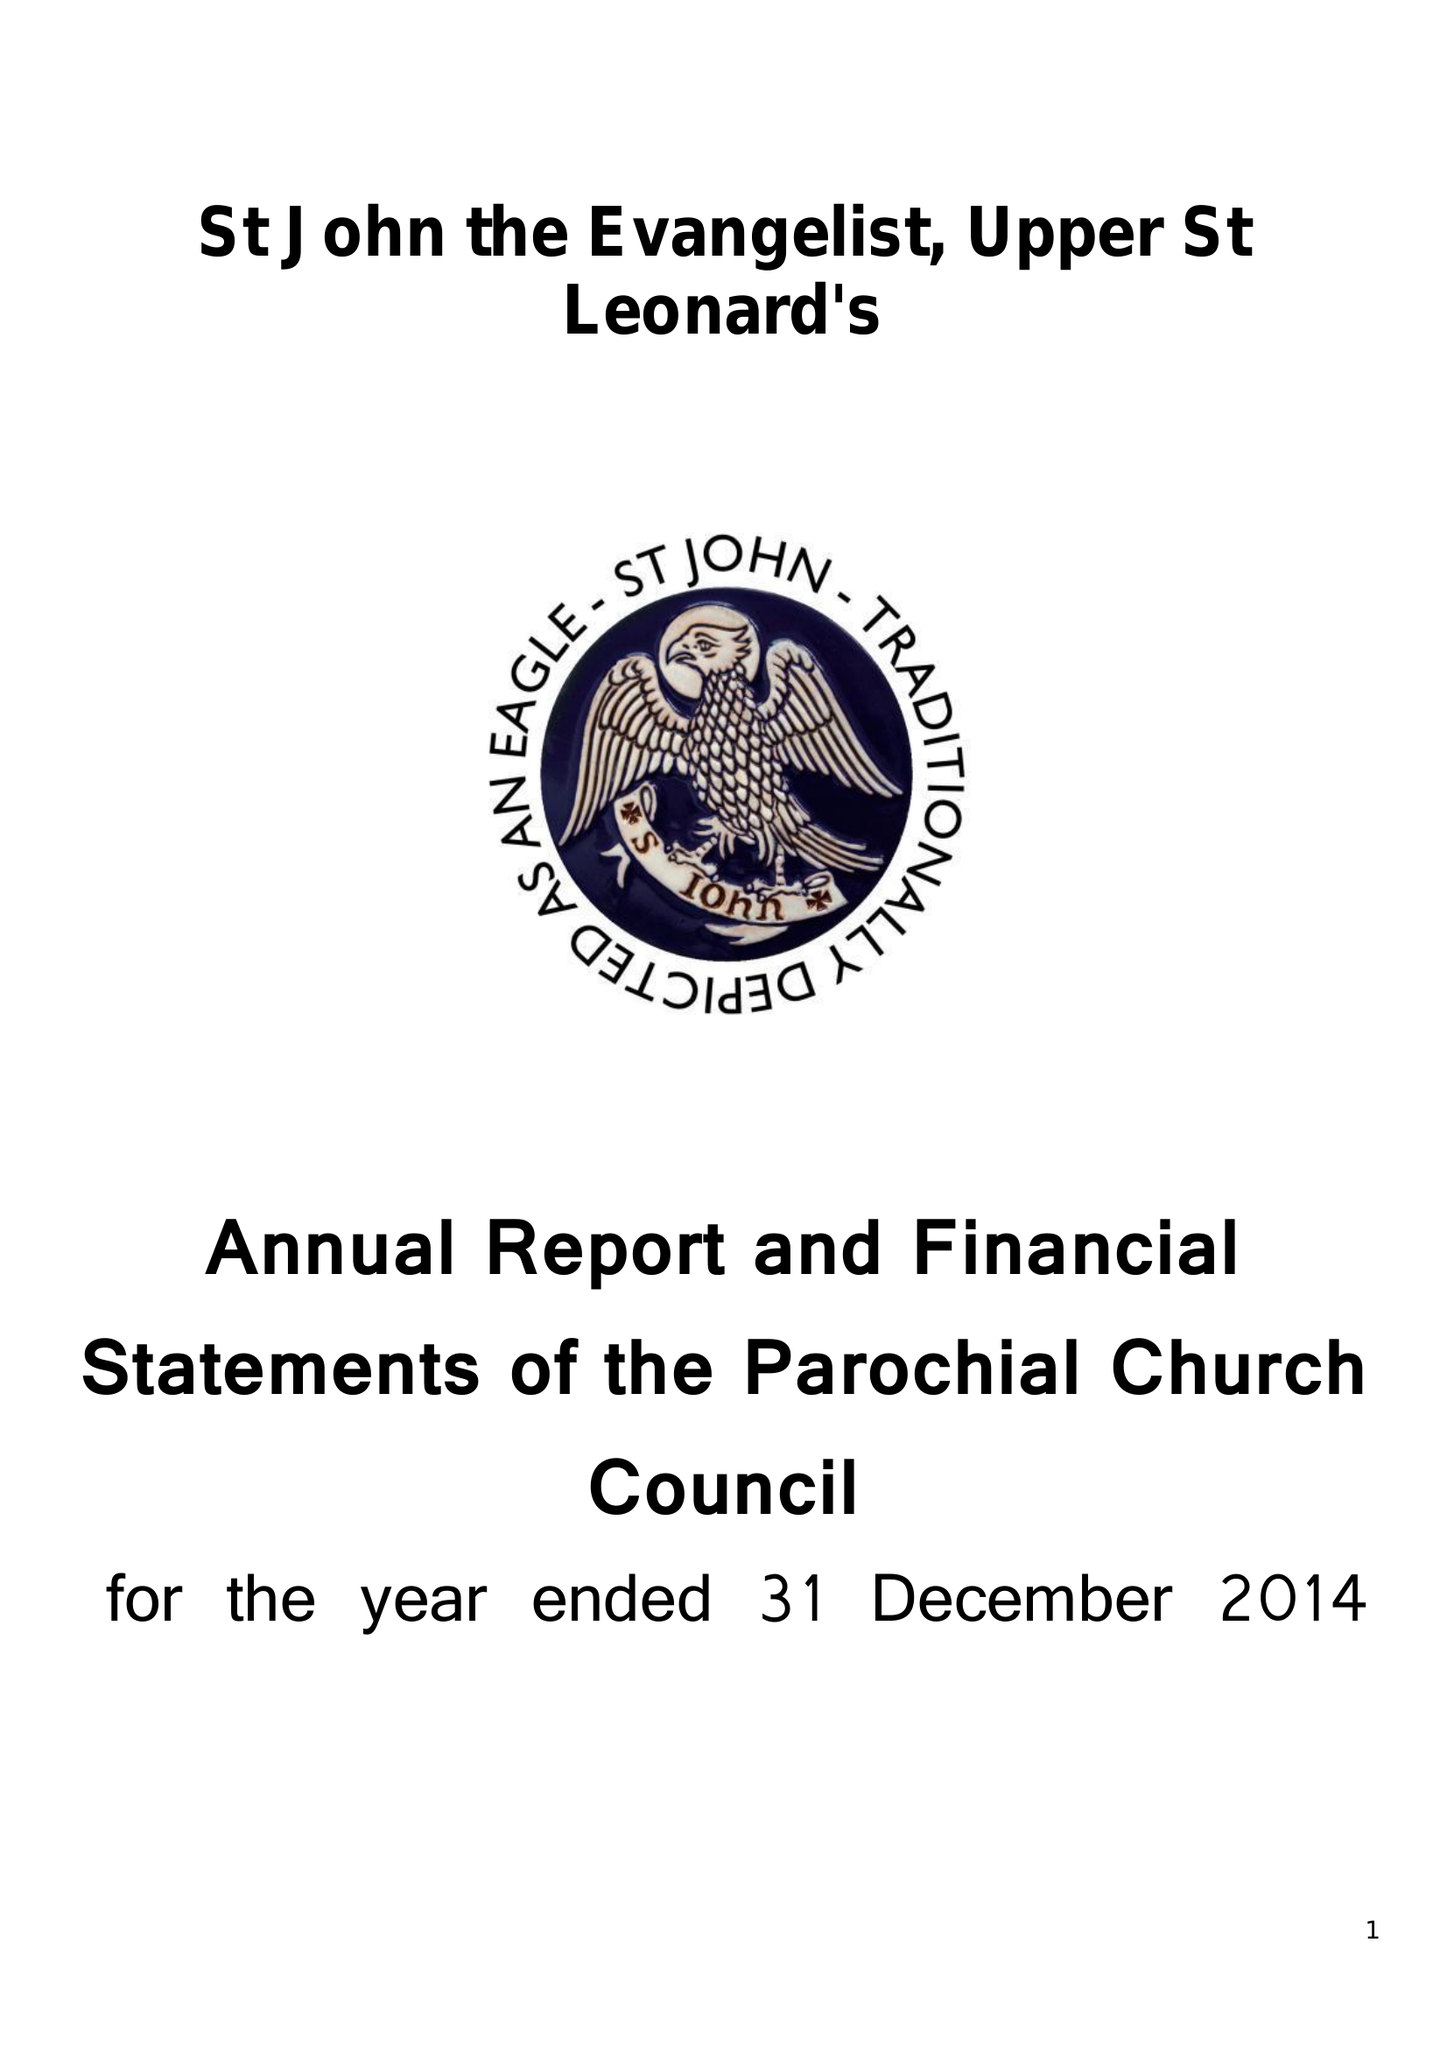What is the value for the address__street_line?
Answer the question using a single word or phrase. PEVENSEY ROAD 